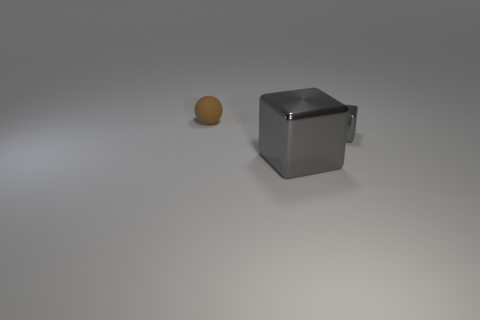What is the shape of the rubber object?
Offer a terse response. Sphere. What color is the thing that is both behind the large block and in front of the brown ball?
Your response must be concise. Gray. What is the material of the big gray cube?
Provide a short and direct response. Metal. What shape is the tiny rubber thing behind the big gray metal thing?
Make the answer very short. Sphere. The other thing that is the same size as the brown rubber thing is what color?
Keep it short and to the point. Gray. Does the gray block that is on the left side of the tiny shiny block have the same material as the tiny block?
Your response must be concise. Yes. How big is the thing that is both behind the big metal block and right of the rubber object?
Your response must be concise. Small. What is the size of the metallic object that is behind the big gray block?
Your answer should be very brief. Small. What is the shape of the object behind the gray shiny block that is behind the cube left of the small gray shiny object?
Give a very brief answer. Sphere. How many other objects are there of the same shape as the big gray object?
Ensure brevity in your answer.  1. 